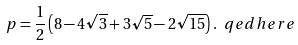<formula> <loc_0><loc_0><loc_500><loc_500>p = \frac { 1 } { 2 } \left ( 8 - 4 \sqrt { 3 } + 3 \sqrt { 5 } - 2 \sqrt { 1 5 } \right ) . \ q e d h e r e</formula> 